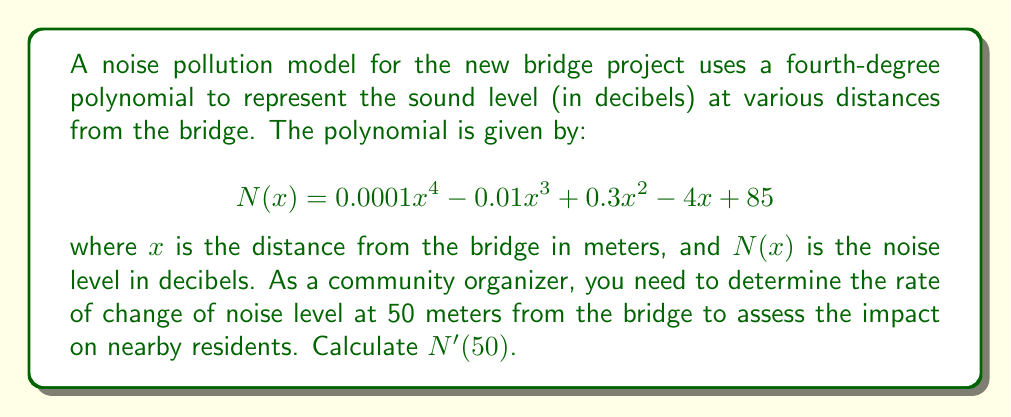Show me your answer to this math problem. To find the rate of change of the noise level at 50 meters from the bridge, we need to calculate the derivative of $N(x)$ and then evaluate it at $x = 50$.

Step 1: Find the derivative of $N(x)$
Using the power rule and the constant rule of differentiation:

$$ N'(x) = 0.0001 \cdot 4x^3 - 0.01 \cdot 3x^2 + 0.3 \cdot 2x - 4 $$

$$ N'(x) = 0.0004x^3 - 0.03x^2 + 0.6x - 4 $$

Step 2: Evaluate $N'(x)$ at $x = 50$

$$ N'(50) = 0.0004(50^3) - 0.03(50^2) + 0.6(50) - 4 $$

$$ N'(50) = 0.0004(125000) - 0.03(2500) + 0.6(50) - 4 $$

$$ N'(50) = 50 - 75 + 30 - 4 $$

$$ N'(50) = 1 $$

The result is positive, indicating that the noise level is still increasing at 50 meters from the bridge, but at a relatively slow rate of 1 decibel per meter.
Answer: $N'(50) = 1$ dB/m 